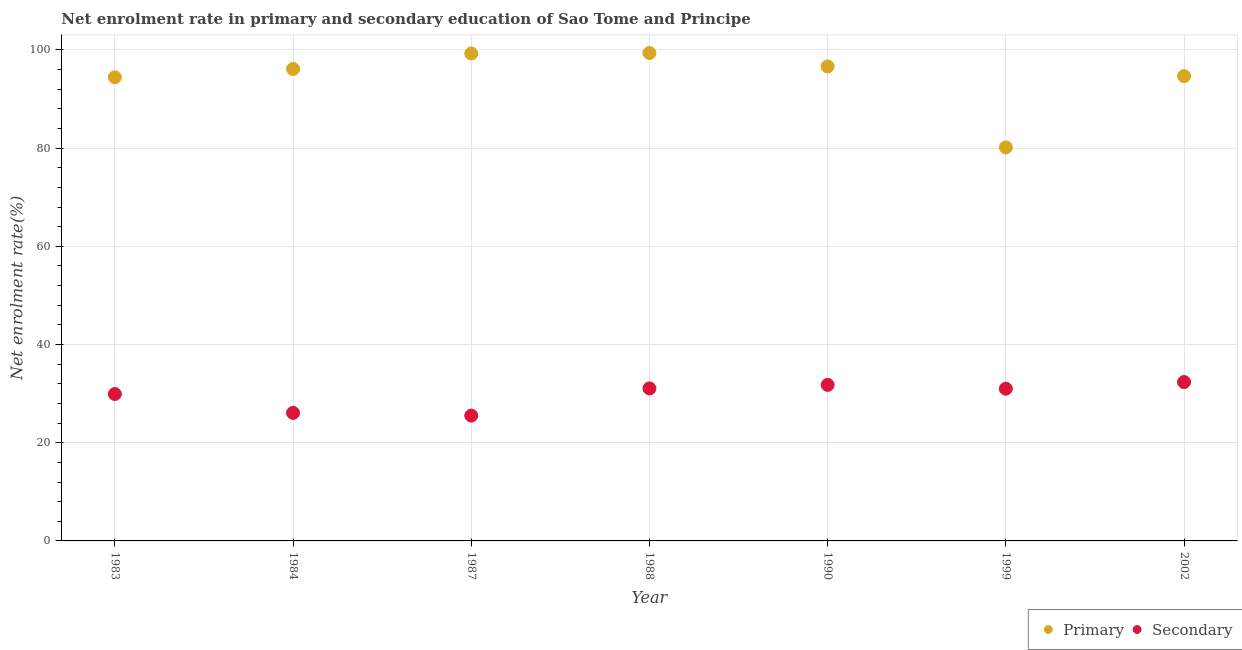Is the number of dotlines equal to the number of legend labels?
Offer a terse response. Yes. What is the enrollment rate in primary education in 1988?
Provide a succinct answer. 99.38. Across all years, what is the maximum enrollment rate in primary education?
Your answer should be compact. 99.38. Across all years, what is the minimum enrollment rate in primary education?
Offer a very short reply. 80.15. In which year was the enrollment rate in primary education maximum?
Ensure brevity in your answer.  1988. In which year was the enrollment rate in primary education minimum?
Provide a short and direct response. 1999. What is the total enrollment rate in secondary education in the graph?
Offer a very short reply. 207.74. What is the difference between the enrollment rate in primary education in 1984 and that in 1987?
Provide a short and direct response. -3.15. What is the difference between the enrollment rate in primary education in 1983 and the enrollment rate in secondary education in 1990?
Your answer should be compact. 62.65. What is the average enrollment rate in secondary education per year?
Offer a terse response. 29.68. In the year 1987, what is the difference between the enrollment rate in secondary education and enrollment rate in primary education?
Your answer should be very brief. -73.75. What is the ratio of the enrollment rate in secondary education in 1999 to that in 2002?
Provide a short and direct response. 0.96. Is the difference between the enrollment rate in primary education in 1983 and 1984 greater than the difference between the enrollment rate in secondary education in 1983 and 1984?
Your answer should be compact. No. What is the difference between the highest and the second highest enrollment rate in secondary education?
Your answer should be very brief. 0.58. What is the difference between the highest and the lowest enrollment rate in secondary education?
Make the answer very short. 6.83. Is the enrollment rate in primary education strictly less than the enrollment rate in secondary education over the years?
Keep it short and to the point. No. How many dotlines are there?
Ensure brevity in your answer.  2. Are the values on the major ticks of Y-axis written in scientific E-notation?
Your answer should be compact. No. How many legend labels are there?
Make the answer very short. 2. How are the legend labels stacked?
Offer a very short reply. Horizontal. What is the title of the graph?
Provide a short and direct response. Net enrolment rate in primary and secondary education of Sao Tome and Principe. What is the label or title of the Y-axis?
Offer a terse response. Net enrolment rate(%). What is the Net enrolment rate(%) in Primary in 1983?
Make the answer very short. 94.43. What is the Net enrolment rate(%) of Secondary in 1983?
Provide a short and direct response. 29.92. What is the Net enrolment rate(%) of Primary in 1984?
Your answer should be compact. 96.13. What is the Net enrolment rate(%) in Secondary in 1984?
Provide a short and direct response. 26.08. What is the Net enrolment rate(%) in Primary in 1987?
Ensure brevity in your answer.  99.28. What is the Net enrolment rate(%) in Secondary in 1987?
Ensure brevity in your answer.  25.53. What is the Net enrolment rate(%) of Primary in 1988?
Make the answer very short. 99.38. What is the Net enrolment rate(%) of Secondary in 1988?
Give a very brief answer. 31.06. What is the Net enrolment rate(%) of Primary in 1990?
Make the answer very short. 96.65. What is the Net enrolment rate(%) of Secondary in 1990?
Ensure brevity in your answer.  31.78. What is the Net enrolment rate(%) in Primary in 1999?
Give a very brief answer. 80.15. What is the Net enrolment rate(%) in Secondary in 1999?
Your response must be concise. 31.01. What is the Net enrolment rate(%) in Primary in 2002?
Offer a terse response. 94.67. What is the Net enrolment rate(%) of Secondary in 2002?
Your answer should be very brief. 32.36. Across all years, what is the maximum Net enrolment rate(%) in Primary?
Offer a terse response. 99.38. Across all years, what is the maximum Net enrolment rate(%) of Secondary?
Keep it short and to the point. 32.36. Across all years, what is the minimum Net enrolment rate(%) of Primary?
Provide a short and direct response. 80.15. Across all years, what is the minimum Net enrolment rate(%) of Secondary?
Give a very brief answer. 25.53. What is the total Net enrolment rate(%) in Primary in the graph?
Your answer should be compact. 660.68. What is the total Net enrolment rate(%) in Secondary in the graph?
Your answer should be very brief. 207.74. What is the difference between the Net enrolment rate(%) of Primary in 1983 and that in 1984?
Your response must be concise. -1.69. What is the difference between the Net enrolment rate(%) of Secondary in 1983 and that in 1984?
Make the answer very short. 3.85. What is the difference between the Net enrolment rate(%) of Primary in 1983 and that in 1987?
Keep it short and to the point. -4.85. What is the difference between the Net enrolment rate(%) in Secondary in 1983 and that in 1987?
Offer a terse response. 4.39. What is the difference between the Net enrolment rate(%) in Primary in 1983 and that in 1988?
Offer a terse response. -4.95. What is the difference between the Net enrolment rate(%) of Secondary in 1983 and that in 1988?
Your answer should be very brief. -1.14. What is the difference between the Net enrolment rate(%) in Primary in 1983 and that in 1990?
Offer a very short reply. -2.21. What is the difference between the Net enrolment rate(%) in Secondary in 1983 and that in 1990?
Offer a terse response. -1.86. What is the difference between the Net enrolment rate(%) in Primary in 1983 and that in 1999?
Ensure brevity in your answer.  14.28. What is the difference between the Net enrolment rate(%) of Secondary in 1983 and that in 1999?
Make the answer very short. -1.08. What is the difference between the Net enrolment rate(%) in Primary in 1983 and that in 2002?
Your answer should be compact. -0.24. What is the difference between the Net enrolment rate(%) of Secondary in 1983 and that in 2002?
Provide a succinct answer. -2.43. What is the difference between the Net enrolment rate(%) in Primary in 1984 and that in 1987?
Give a very brief answer. -3.15. What is the difference between the Net enrolment rate(%) in Secondary in 1984 and that in 1987?
Your answer should be very brief. 0.55. What is the difference between the Net enrolment rate(%) of Primary in 1984 and that in 1988?
Your answer should be very brief. -3.25. What is the difference between the Net enrolment rate(%) in Secondary in 1984 and that in 1988?
Make the answer very short. -4.98. What is the difference between the Net enrolment rate(%) in Primary in 1984 and that in 1990?
Make the answer very short. -0.52. What is the difference between the Net enrolment rate(%) in Secondary in 1984 and that in 1990?
Make the answer very short. -5.7. What is the difference between the Net enrolment rate(%) in Primary in 1984 and that in 1999?
Provide a succinct answer. 15.97. What is the difference between the Net enrolment rate(%) in Secondary in 1984 and that in 1999?
Give a very brief answer. -4.93. What is the difference between the Net enrolment rate(%) of Primary in 1984 and that in 2002?
Offer a terse response. 1.46. What is the difference between the Net enrolment rate(%) in Secondary in 1984 and that in 2002?
Offer a terse response. -6.28. What is the difference between the Net enrolment rate(%) in Primary in 1987 and that in 1988?
Your answer should be very brief. -0.1. What is the difference between the Net enrolment rate(%) of Secondary in 1987 and that in 1988?
Your answer should be compact. -5.53. What is the difference between the Net enrolment rate(%) of Primary in 1987 and that in 1990?
Offer a terse response. 2.63. What is the difference between the Net enrolment rate(%) in Secondary in 1987 and that in 1990?
Your answer should be compact. -6.25. What is the difference between the Net enrolment rate(%) of Primary in 1987 and that in 1999?
Make the answer very short. 19.13. What is the difference between the Net enrolment rate(%) in Secondary in 1987 and that in 1999?
Offer a very short reply. -5.48. What is the difference between the Net enrolment rate(%) of Primary in 1987 and that in 2002?
Keep it short and to the point. 4.61. What is the difference between the Net enrolment rate(%) of Secondary in 1987 and that in 2002?
Your response must be concise. -6.83. What is the difference between the Net enrolment rate(%) in Primary in 1988 and that in 1990?
Your answer should be very brief. 2.73. What is the difference between the Net enrolment rate(%) in Secondary in 1988 and that in 1990?
Offer a terse response. -0.72. What is the difference between the Net enrolment rate(%) in Primary in 1988 and that in 1999?
Ensure brevity in your answer.  19.22. What is the difference between the Net enrolment rate(%) of Secondary in 1988 and that in 1999?
Your answer should be compact. 0.05. What is the difference between the Net enrolment rate(%) of Primary in 1988 and that in 2002?
Make the answer very short. 4.71. What is the difference between the Net enrolment rate(%) in Secondary in 1988 and that in 2002?
Your answer should be compact. -1.3. What is the difference between the Net enrolment rate(%) of Primary in 1990 and that in 1999?
Offer a very short reply. 16.49. What is the difference between the Net enrolment rate(%) of Secondary in 1990 and that in 1999?
Offer a terse response. 0.77. What is the difference between the Net enrolment rate(%) in Primary in 1990 and that in 2002?
Your response must be concise. 1.98. What is the difference between the Net enrolment rate(%) of Secondary in 1990 and that in 2002?
Give a very brief answer. -0.58. What is the difference between the Net enrolment rate(%) of Primary in 1999 and that in 2002?
Ensure brevity in your answer.  -14.52. What is the difference between the Net enrolment rate(%) of Secondary in 1999 and that in 2002?
Give a very brief answer. -1.35. What is the difference between the Net enrolment rate(%) in Primary in 1983 and the Net enrolment rate(%) in Secondary in 1984?
Make the answer very short. 68.35. What is the difference between the Net enrolment rate(%) in Primary in 1983 and the Net enrolment rate(%) in Secondary in 1987?
Offer a very short reply. 68.9. What is the difference between the Net enrolment rate(%) of Primary in 1983 and the Net enrolment rate(%) of Secondary in 1988?
Keep it short and to the point. 63.37. What is the difference between the Net enrolment rate(%) of Primary in 1983 and the Net enrolment rate(%) of Secondary in 1990?
Make the answer very short. 62.65. What is the difference between the Net enrolment rate(%) of Primary in 1983 and the Net enrolment rate(%) of Secondary in 1999?
Offer a terse response. 63.42. What is the difference between the Net enrolment rate(%) in Primary in 1983 and the Net enrolment rate(%) in Secondary in 2002?
Offer a terse response. 62.08. What is the difference between the Net enrolment rate(%) of Primary in 1984 and the Net enrolment rate(%) of Secondary in 1987?
Offer a terse response. 70.6. What is the difference between the Net enrolment rate(%) of Primary in 1984 and the Net enrolment rate(%) of Secondary in 1988?
Make the answer very short. 65.06. What is the difference between the Net enrolment rate(%) of Primary in 1984 and the Net enrolment rate(%) of Secondary in 1990?
Your answer should be compact. 64.35. What is the difference between the Net enrolment rate(%) in Primary in 1984 and the Net enrolment rate(%) in Secondary in 1999?
Provide a succinct answer. 65.12. What is the difference between the Net enrolment rate(%) of Primary in 1984 and the Net enrolment rate(%) of Secondary in 2002?
Provide a succinct answer. 63.77. What is the difference between the Net enrolment rate(%) in Primary in 1987 and the Net enrolment rate(%) in Secondary in 1988?
Keep it short and to the point. 68.22. What is the difference between the Net enrolment rate(%) of Primary in 1987 and the Net enrolment rate(%) of Secondary in 1990?
Offer a terse response. 67.5. What is the difference between the Net enrolment rate(%) of Primary in 1987 and the Net enrolment rate(%) of Secondary in 1999?
Keep it short and to the point. 68.27. What is the difference between the Net enrolment rate(%) in Primary in 1987 and the Net enrolment rate(%) in Secondary in 2002?
Your answer should be very brief. 66.92. What is the difference between the Net enrolment rate(%) of Primary in 1988 and the Net enrolment rate(%) of Secondary in 1990?
Offer a terse response. 67.6. What is the difference between the Net enrolment rate(%) of Primary in 1988 and the Net enrolment rate(%) of Secondary in 1999?
Give a very brief answer. 68.37. What is the difference between the Net enrolment rate(%) of Primary in 1988 and the Net enrolment rate(%) of Secondary in 2002?
Keep it short and to the point. 67.02. What is the difference between the Net enrolment rate(%) in Primary in 1990 and the Net enrolment rate(%) in Secondary in 1999?
Your response must be concise. 65.64. What is the difference between the Net enrolment rate(%) in Primary in 1990 and the Net enrolment rate(%) in Secondary in 2002?
Your answer should be compact. 64.29. What is the difference between the Net enrolment rate(%) of Primary in 1999 and the Net enrolment rate(%) of Secondary in 2002?
Keep it short and to the point. 47.8. What is the average Net enrolment rate(%) in Primary per year?
Ensure brevity in your answer.  94.38. What is the average Net enrolment rate(%) of Secondary per year?
Your answer should be compact. 29.68. In the year 1983, what is the difference between the Net enrolment rate(%) in Primary and Net enrolment rate(%) in Secondary?
Provide a short and direct response. 64.51. In the year 1984, what is the difference between the Net enrolment rate(%) in Primary and Net enrolment rate(%) in Secondary?
Your answer should be compact. 70.05. In the year 1987, what is the difference between the Net enrolment rate(%) of Primary and Net enrolment rate(%) of Secondary?
Your answer should be very brief. 73.75. In the year 1988, what is the difference between the Net enrolment rate(%) in Primary and Net enrolment rate(%) in Secondary?
Give a very brief answer. 68.32. In the year 1990, what is the difference between the Net enrolment rate(%) in Primary and Net enrolment rate(%) in Secondary?
Make the answer very short. 64.87. In the year 1999, what is the difference between the Net enrolment rate(%) of Primary and Net enrolment rate(%) of Secondary?
Give a very brief answer. 49.14. In the year 2002, what is the difference between the Net enrolment rate(%) of Primary and Net enrolment rate(%) of Secondary?
Keep it short and to the point. 62.31. What is the ratio of the Net enrolment rate(%) in Primary in 1983 to that in 1984?
Your answer should be very brief. 0.98. What is the ratio of the Net enrolment rate(%) in Secondary in 1983 to that in 1984?
Your response must be concise. 1.15. What is the ratio of the Net enrolment rate(%) of Primary in 1983 to that in 1987?
Make the answer very short. 0.95. What is the ratio of the Net enrolment rate(%) of Secondary in 1983 to that in 1987?
Your answer should be very brief. 1.17. What is the ratio of the Net enrolment rate(%) of Primary in 1983 to that in 1988?
Offer a terse response. 0.95. What is the ratio of the Net enrolment rate(%) in Secondary in 1983 to that in 1988?
Offer a very short reply. 0.96. What is the ratio of the Net enrolment rate(%) of Primary in 1983 to that in 1990?
Keep it short and to the point. 0.98. What is the ratio of the Net enrolment rate(%) of Secondary in 1983 to that in 1990?
Ensure brevity in your answer.  0.94. What is the ratio of the Net enrolment rate(%) of Primary in 1983 to that in 1999?
Offer a terse response. 1.18. What is the ratio of the Net enrolment rate(%) of Primary in 1983 to that in 2002?
Your answer should be very brief. 1. What is the ratio of the Net enrolment rate(%) in Secondary in 1983 to that in 2002?
Offer a very short reply. 0.92. What is the ratio of the Net enrolment rate(%) in Primary in 1984 to that in 1987?
Offer a very short reply. 0.97. What is the ratio of the Net enrolment rate(%) in Secondary in 1984 to that in 1987?
Offer a terse response. 1.02. What is the ratio of the Net enrolment rate(%) in Primary in 1984 to that in 1988?
Your answer should be compact. 0.97. What is the ratio of the Net enrolment rate(%) of Secondary in 1984 to that in 1988?
Ensure brevity in your answer.  0.84. What is the ratio of the Net enrolment rate(%) in Primary in 1984 to that in 1990?
Provide a succinct answer. 0.99. What is the ratio of the Net enrolment rate(%) of Secondary in 1984 to that in 1990?
Keep it short and to the point. 0.82. What is the ratio of the Net enrolment rate(%) in Primary in 1984 to that in 1999?
Your answer should be compact. 1.2. What is the ratio of the Net enrolment rate(%) in Secondary in 1984 to that in 1999?
Offer a very short reply. 0.84. What is the ratio of the Net enrolment rate(%) in Primary in 1984 to that in 2002?
Your answer should be very brief. 1.02. What is the ratio of the Net enrolment rate(%) in Secondary in 1984 to that in 2002?
Keep it short and to the point. 0.81. What is the ratio of the Net enrolment rate(%) in Primary in 1987 to that in 1988?
Your response must be concise. 1. What is the ratio of the Net enrolment rate(%) of Secondary in 1987 to that in 1988?
Make the answer very short. 0.82. What is the ratio of the Net enrolment rate(%) in Primary in 1987 to that in 1990?
Offer a terse response. 1.03. What is the ratio of the Net enrolment rate(%) of Secondary in 1987 to that in 1990?
Give a very brief answer. 0.8. What is the ratio of the Net enrolment rate(%) in Primary in 1987 to that in 1999?
Your answer should be compact. 1.24. What is the ratio of the Net enrolment rate(%) in Secondary in 1987 to that in 1999?
Keep it short and to the point. 0.82. What is the ratio of the Net enrolment rate(%) of Primary in 1987 to that in 2002?
Your response must be concise. 1.05. What is the ratio of the Net enrolment rate(%) in Secondary in 1987 to that in 2002?
Your response must be concise. 0.79. What is the ratio of the Net enrolment rate(%) of Primary in 1988 to that in 1990?
Offer a very short reply. 1.03. What is the ratio of the Net enrolment rate(%) in Secondary in 1988 to that in 1990?
Provide a short and direct response. 0.98. What is the ratio of the Net enrolment rate(%) of Primary in 1988 to that in 1999?
Your answer should be very brief. 1.24. What is the ratio of the Net enrolment rate(%) of Secondary in 1988 to that in 1999?
Make the answer very short. 1. What is the ratio of the Net enrolment rate(%) of Primary in 1988 to that in 2002?
Give a very brief answer. 1.05. What is the ratio of the Net enrolment rate(%) of Secondary in 1988 to that in 2002?
Offer a very short reply. 0.96. What is the ratio of the Net enrolment rate(%) in Primary in 1990 to that in 1999?
Provide a succinct answer. 1.21. What is the ratio of the Net enrolment rate(%) in Secondary in 1990 to that in 1999?
Give a very brief answer. 1.02. What is the ratio of the Net enrolment rate(%) in Primary in 1990 to that in 2002?
Your answer should be very brief. 1.02. What is the ratio of the Net enrolment rate(%) of Secondary in 1990 to that in 2002?
Give a very brief answer. 0.98. What is the ratio of the Net enrolment rate(%) in Primary in 1999 to that in 2002?
Your answer should be compact. 0.85. What is the ratio of the Net enrolment rate(%) of Secondary in 1999 to that in 2002?
Your response must be concise. 0.96. What is the difference between the highest and the second highest Net enrolment rate(%) of Primary?
Make the answer very short. 0.1. What is the difference between the highest and the second highest Net enrolment rate(%) in Secondary?
Offer a very short reply. 0.58. What is the difference between the highest and the lowest Net enrolment rate(%) in Primary?
Make the answer very short. 19.22. What is the difference between the highest and the lowest Net enrolment rate(%) of Secondary?
Provide a succinct answer. 6.83. 